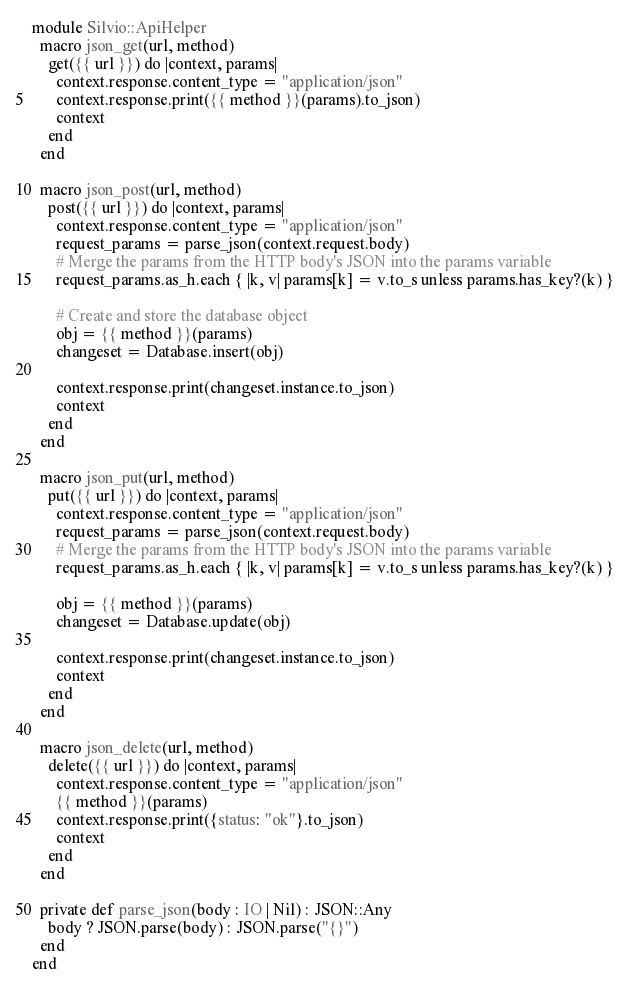Convert code to text. <code><loc_0><loc_0><loc_500><loc_500><_Crystal_>module Silvio::ApiHelper
  macro json_get(url, method)
    get({{ url }}) do |context, params|
      context.response.content_type = "application/json"
      context.response.print({{ method }}(params).to_json)
      context
    end
  end

  macro json_post(url, method)
    post({{ url }}) do |context, params|
      context.response.content_type = "application/json"
      request_params = parse_json(context.request.body)
      # Merge the params from the HTTP body's JSON into the params variable
      request_params.as_h.each { |k, v| params[k] = v.to_s unless params.has_key?(k) }

      # Create and store the database object
      obj = {{ method }}(params)
      changeset = Database.insert(obj)

      context.response.print(changeset.instance.to_json)
      context
    end
  end

  macro json_put(url, method)
    put({{ url }}) do |context, params|
      context.response.content_type = "application/json"
      request_params = parse_json(context.request.body)
      # Merge the params from the HTTP body's JSON into the params variable
      request_params.as_h.each { |k, v| params[k] = v.to_s unless params.has_key?(k) }

      obj = {{ method }}(params)
      changeset = Database.update(obj)

      context.response.print(changeset.instance.to_json)
      context
    end
  end

  macro json_delete(url, method)
    delete({{ url }}) do |context, params|
      context.response.content_type = "application/json"
      {{ method }}(params)
      context.response.print({status: "ok"}.to_json)
      context
    end
  end

  private def parse_json(body : IO | Nil) : JSON::Any
    body ? JSON.parse(body) : JSON.parse("{}")
  end
end
</code> 